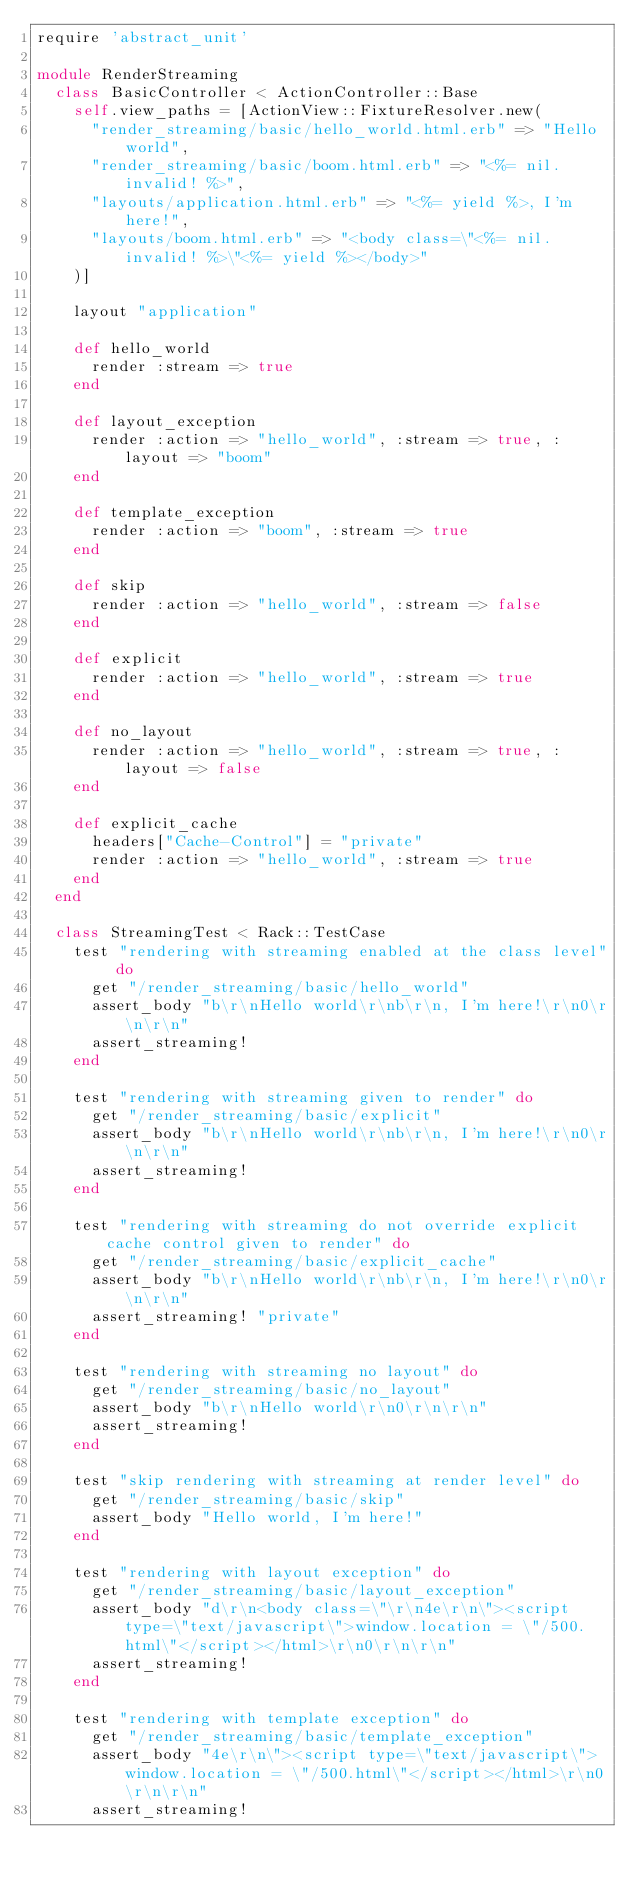Convert code to text. <code><loc_0><loc_0><loc_500><loc_500><_Ruby_>require 'abstract_unit'

module RenderStreaming
  class BasicController < ActionController::Base
    self.view_paths = [ActionView::FixtureResolver.new(
      "render_streaming/basic/hello_world.html.erb" => "Hello world",
      "render_streaming/basic/boom.html.erb" => "<%= nil.invalid! %>",
      "layouts/application.html.erb" => "<%= yield %>, I'm here!",
      "layouts/boom.html.erb" => "<body class=\"<%= nil.invalid! %>\"<%= yield %></body>"
    )]

    layout "application"

    def hello_world
      render :stream => true
    end

    def layout_exception
      render :action => "hello_world", :stream => true, :layout => "boom"
    end

    def template_exception
      render :action => "boom", :stream => true
    end

    def skip
      render :action => "hello_world", :stream => false
    end

    def explicit
      render :action => "hello_world", :stream => true
    end

    def no_layout
      render :action => "hello_world", :stream => true, :layout => false
    end

    def explicit_cache
      headers["Cache-Control"] = "private"
      render :action => "hello_world", :stream => true
    end
  end

  class StreamingTest < Rack::TestCase
    test "rendering with streaming enabled at the class level" do
      get "/render_streaming/basic/hello_world"
      assert_body "b\r\nHello world\r\nb\r\n, I'm here!\r\n0\r\n\r\n"
      assert_streaming!
    end

    test "rendering with streaming given to render" do
      get "/render_streaming/basic/explicit"
      assert_body "b\r\nHello world\r\nb\r\n, I'm here!\r\n0\r\n\r\n"
      assert_streaming!
    end

    test "rendering with streaming do not override explicit cache control given to render" do
      get "/render_streaming/basic/explicit_cache"
      assert_body "b\r\nHello world\r\nb\r\n, I'm here!\r\n0\r\n\r\n"
      assert_streaming! "private"
    end

    test "rendering with streaming no layout" do
      get "/render_streaming/basic/no_layout"
      assert_body "b\r\nHello world\r\n0\r\n\r\n"
      assert_streaming!
    end

    test "skip rendering with streaming at render level" do
      get "/render_streaming/basic/skip"
      assert_body "Hello world, I'm here!"
    end

    test "rendering with layout exception" do
      get "/render_streaming/basic/layout_exception"
      assert_body "d\r\n<body class=\"\r\n4e\r\n\"><script type=\"text/javascript\">window.location = \"/500.html\"</script></html>\r\n0\r\n\r\n"
      assert_streaming!
    end

    test "rendering with template exception" do
      get "/render_streaming/basic/template_exception"
      assert_body "4e\r\n\"><script type=\"text/javascript\">window.location = \"/500.html\"</script></html>\r\n0\r\n\r\n"
      assert_streaming!</code> 